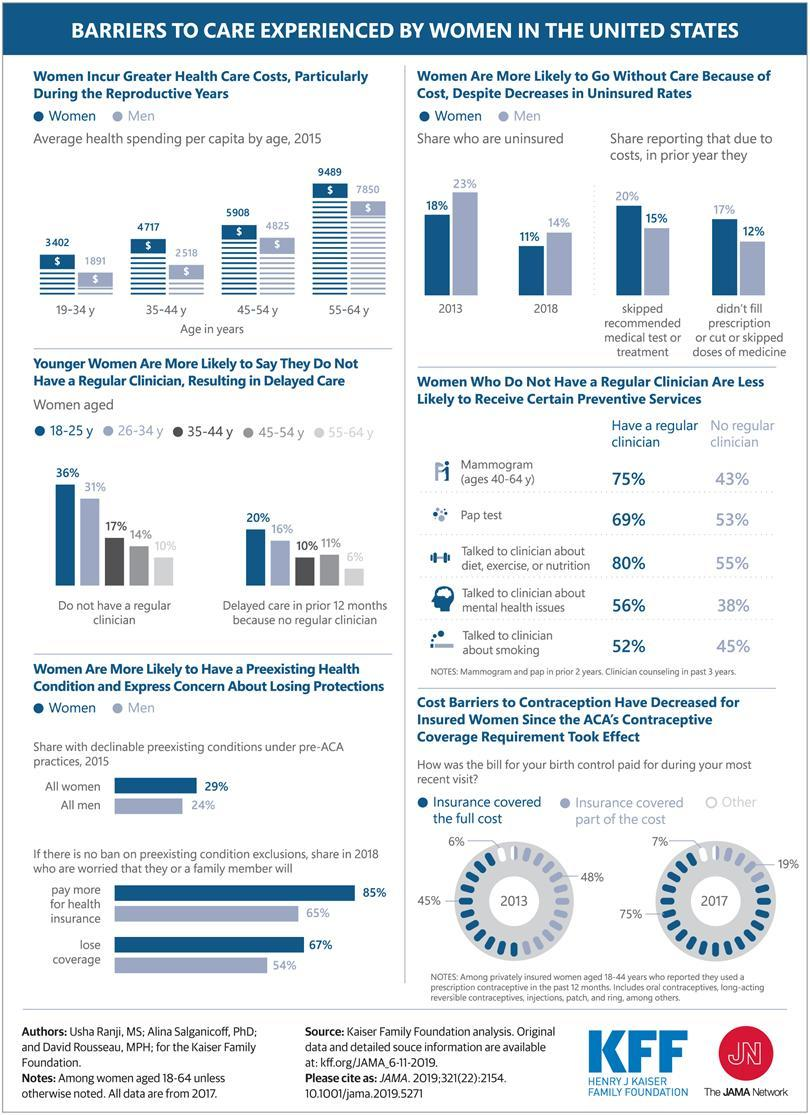How much is the decrease in the percentage of women who are uninsured from the year 2013 to 2018?
Answer the question with a short phrase. 7 How much more is the health cost of senior women than men? 1,639 How much more is the health cost of young women than men? 1,511 What percentage of 45- 54 year old women do not have regular clinician? 14% How much is the decrease in the percentage of men who are uninsured from the year 2013 to 2018? 9 What percentage of 26- 34 year old women do not have regular clinician? 31% 